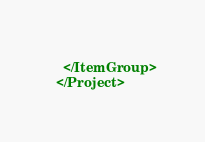<code> <loc_0><loc_0><loc_500><loc_500><_XML_>  </ItemGroup>
</Project>
</code> 